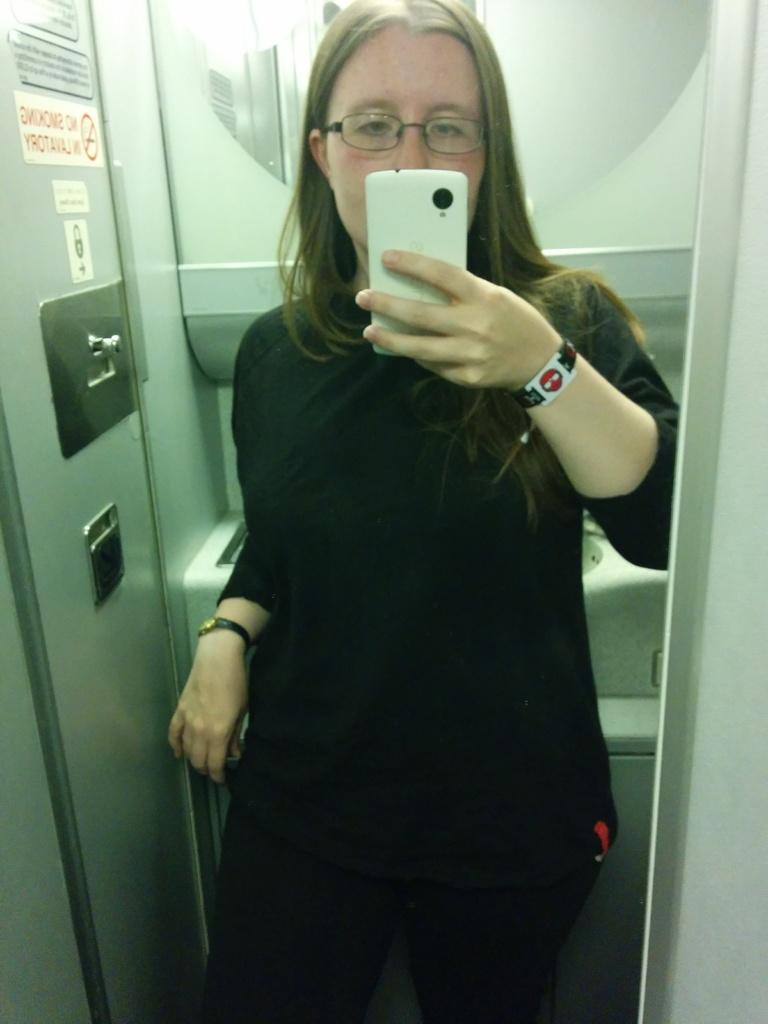Who is the main subject in the image? There is a woman in the image. What is the woman doing in the image? The woman is taking a picture. What type of wrench is the woman using to take the picture in the image? There is no wrench present in the image; the woman is simply taking a picture with a camera or a phone. 